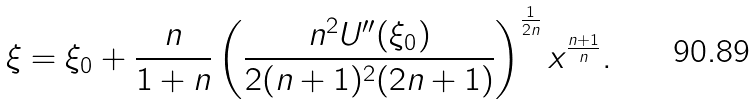Convert formula to latex. <formula><loc_0><loc_0><loc_500><loc_500>\xi = \xi _ { 0 } + \frac { n } { 1 + n } \left ( \frac { n ^ { 2 } U ^ { \prime \prime } ( \xi _ { 0 } ) } { 2 ( n + 1 ) ^ { 2 } ( 2 n + 1 ) } \right ) ^ { \frac { 1 } { 2 n } } x ^ { \frac { n + 1 } { n } } .</formula> 